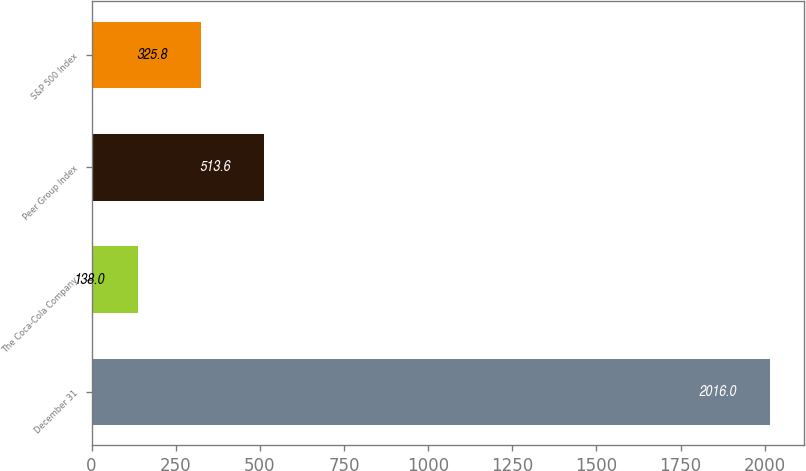Convert chart. <chart><loc_0><loc_0><loc_500><loc_500><bar_chart><fcel>December 31<fcel>The Coca-Cola Company<fcel>Peer Group Index<fcel>S&P 500 Index<nl><fcel>2016<fcel>138<fcel>513.6<fcel>325.8<nl></chart> 